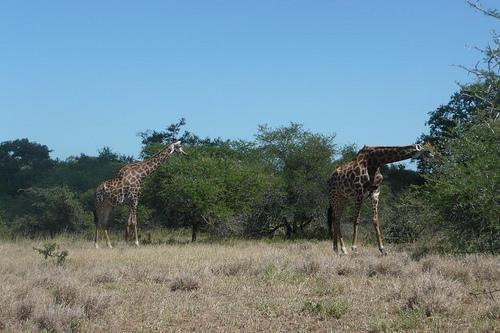How many giraffes are pictured?
Give a very brief answer. 2. 